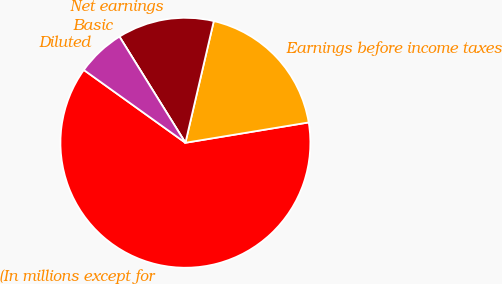Convert chart to OTSL. <chart><loc_0><loc_0><loc_500><loc_500><pie_chart><fcel>(In millions except for<fcel>Earnings before income taxes<fcel>Net earnings<fcel>Basic<fcel>Diluted<nl><fcel>62.5%<fcel>18.75%<fcel>12.5%<fcel>0.0%<fcel>6.25%<nl></chart> 